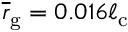<formula> <loc_0><loc_0><loc_500><loc_500>\overline { r } _ { g } = 0 . 0 1 6 \ell _ { c }</formula> 